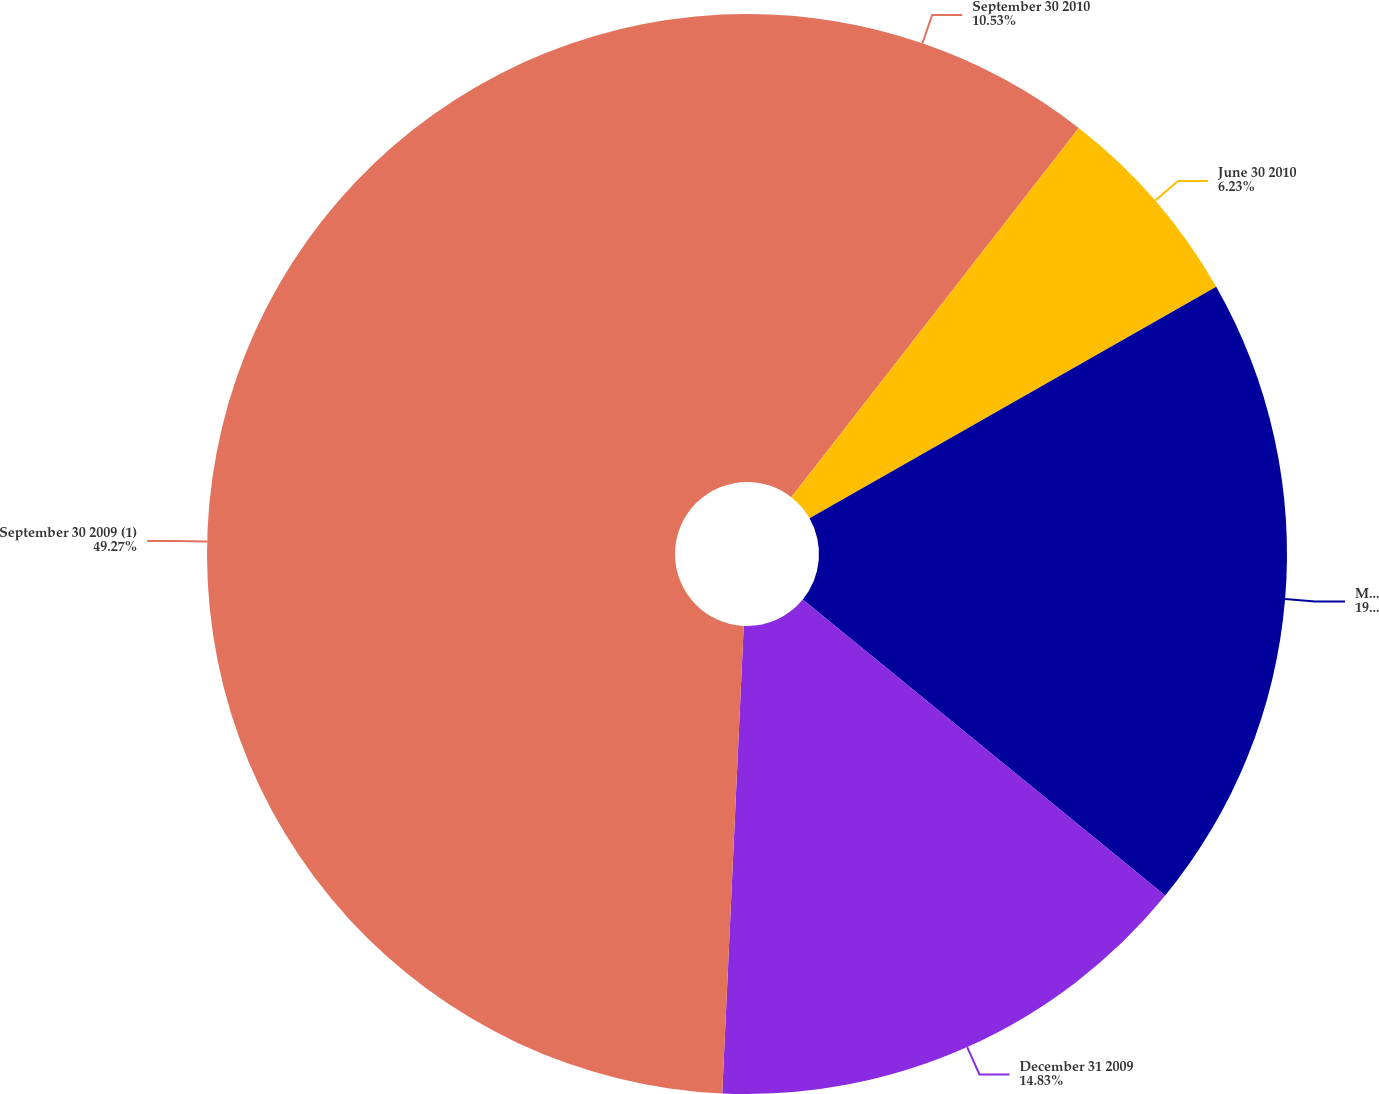Convert chart. <chart><loc_0><loc_0><loc_500><loc_500><pie_chart><fcel>September 30 2010<fcel>June 30 2010<fcel>March 31 2010<fcel>December 31 2009<fcel>September 30 2009 (1)<nl><fcel>10.53%<fcel>6.23%<fcel>19.14%<fcel>14.83%<fcel>49.27%<nl></chart> 